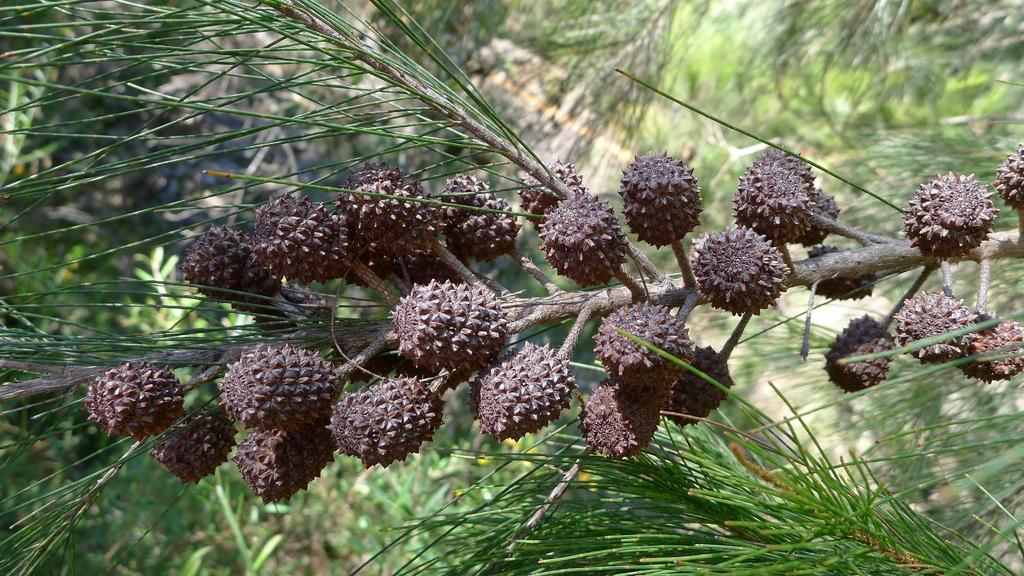What type of fruits can be seen on the tree in the image? There are pine fruits on a branch of a tree in the image. What can be seen in the background of the image? There is a group of trees and plants visible in the background of the image. What is the weight of the bag hanging from the tree in the image? There is no bag hanging from the tree in the image; it only features pine fruits on a branch. 